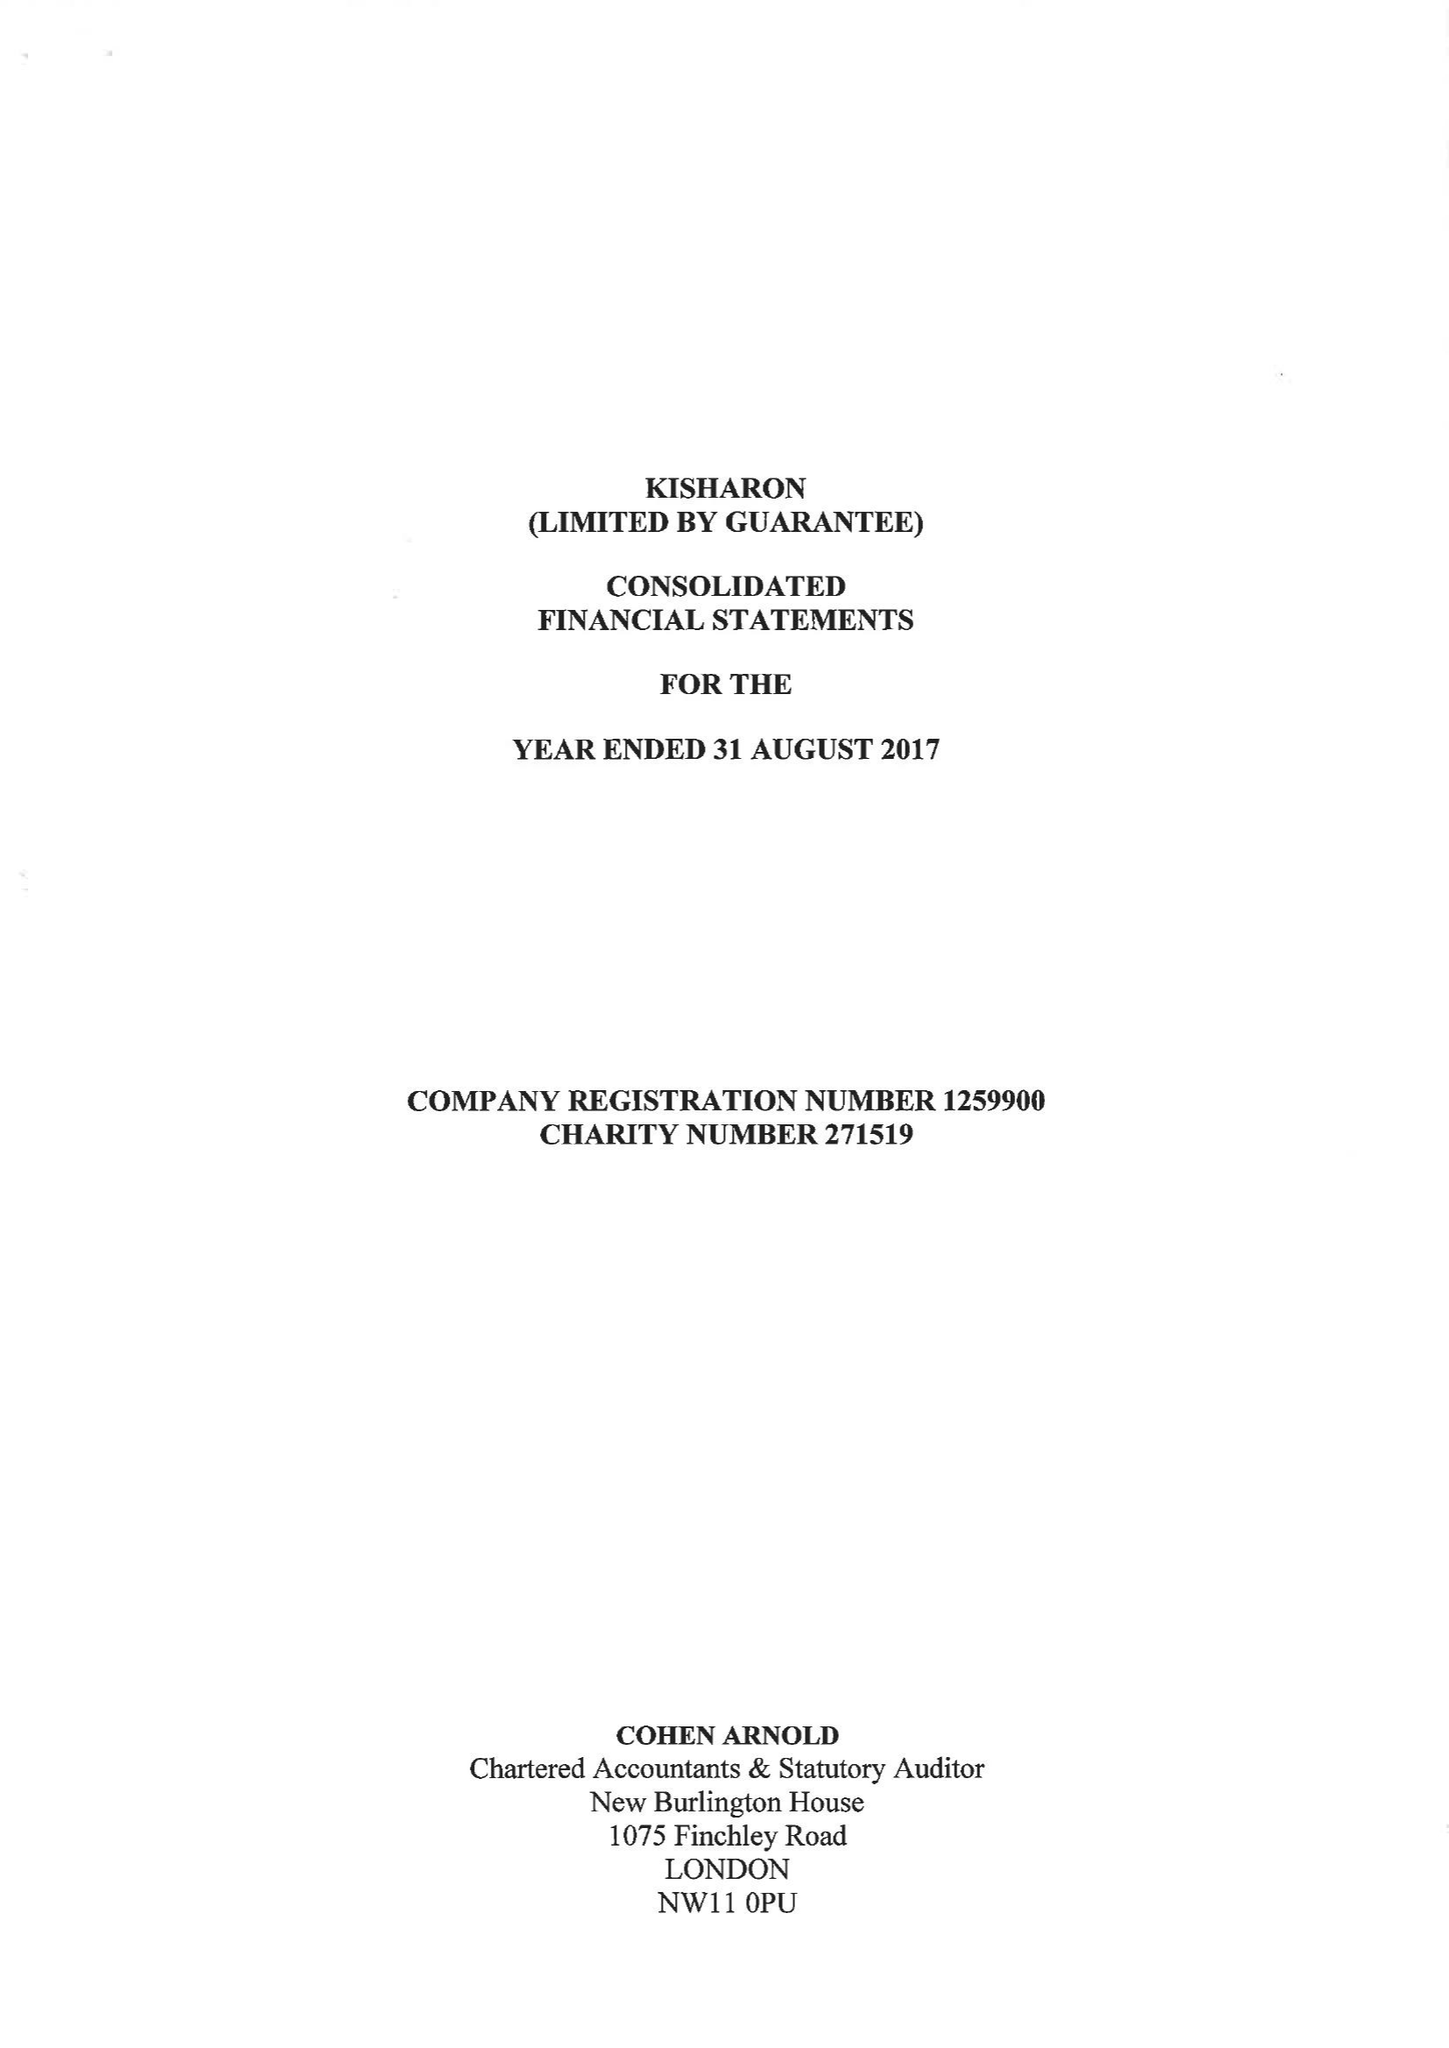What is the value for the income_annually_in_british_pounds?
Answer the question using a single word or phrase. 6549331.00 